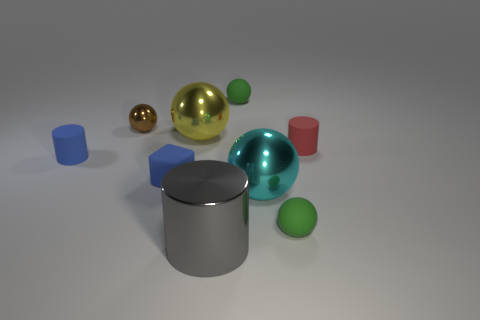Is there a green object of the same shape as the gray thing?
Offer a very short reply. No. What is the shape of the blue matte thing that is the same size as the blue rubber block?
Your response must be concise. Cylinder. What is the shape of the shiny object that is right of the tiny green ball behind the small rubber cylinder on the left side of the large gray cylinder?
Offer a terse response. Sphere. Does the red matte object have the same shape as the metallic thing that is right of the metallic cylinder?
Make the answer very short. No. How many tiny things are gray shiny cylinders or brown shiny cylinders?
Your answer should be compact. 0. Are there any green metallic things that have the same size as the shiny cylinder?
Provide a short and direct response. No. The tiny rubber ball that is in front of the tiny cylinder right of the rubber cylinder left of the small brown metal object is what color?
Ensure brevity in your answer.  Green. Is the material of the blue cylinder the same as the tiny brown object that is behind the small blue matte cylinder?
Provide a short and direct response. No. There is a brown metallic thing that is the same shape as the big yellow object; what size is it?
Your answer should be compact. Small. Are there an equal number of red rubber cylinders that are to the right of the gray shiny cylinder and gray metal things that are behind the blue block?
Give a very brief answer. No. 